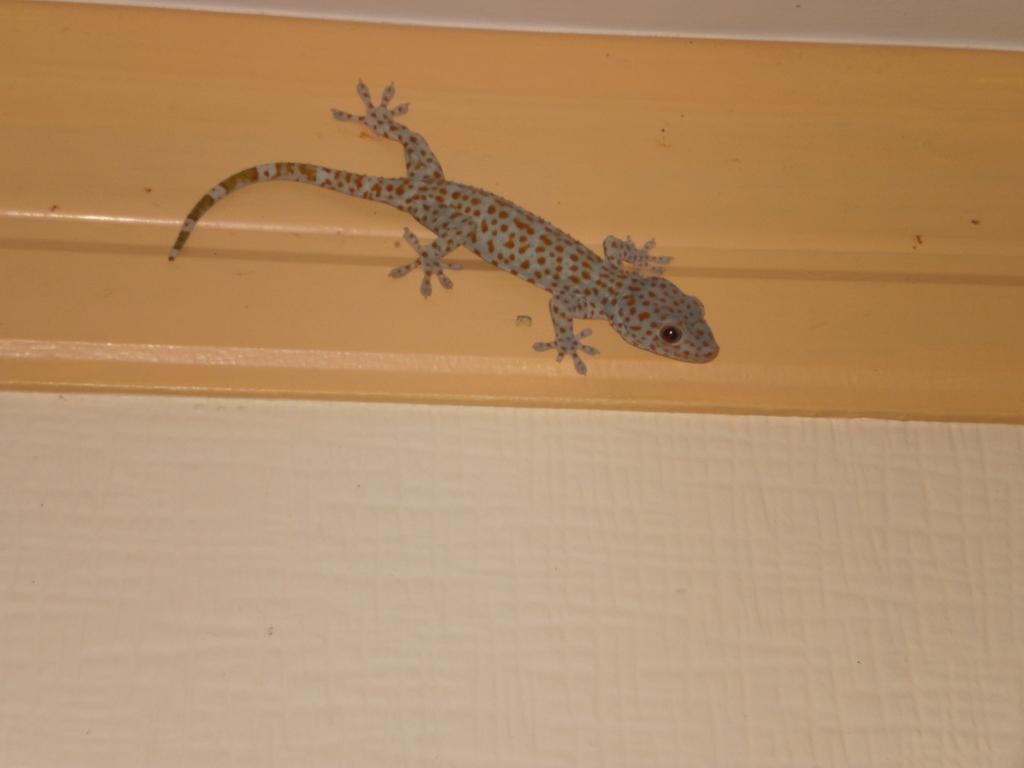Describe this image in one or two sentences. In this image I can see a lizard on the wall. 